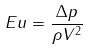<formula> <loc_0><loc_0><loc_500><loc_500>E u = \frac { \Delta p } { \rho V ^ { 2 } }</formula> 